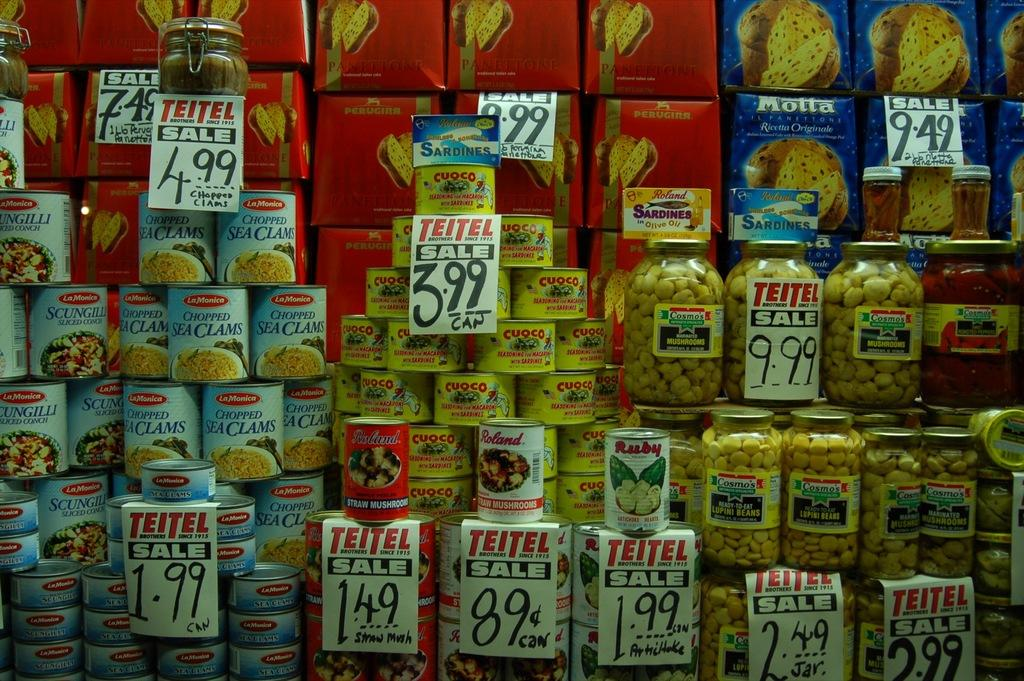Provide a one-sentence caption for the provided image. cans of clam, bread, and other items are stacked on top of each other on a shelf. 